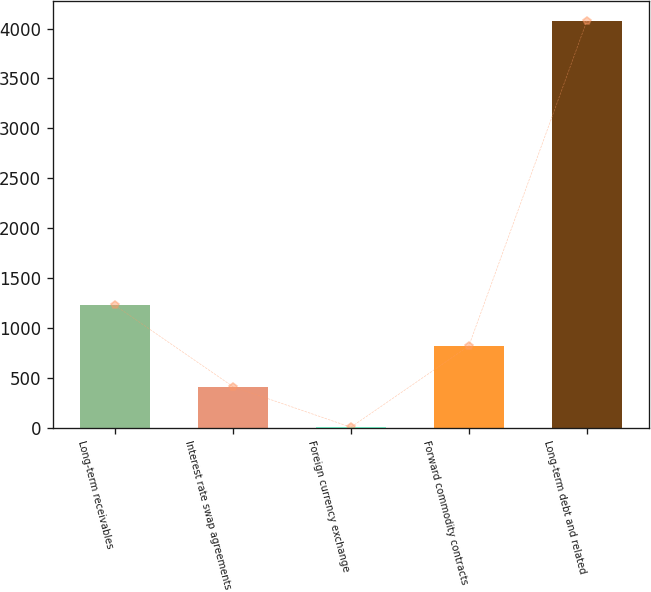Convert chart to OTSL. <chart><loc_0><loc_0><loc_500><loc_500><bar_chart><fcel>Long-term receivables<fcel>Interest rate swap agreements<fcel>Foreign currency exchange<fcel>Forward commodity contracts<fcel>Long-term debt and related<nl><fcel>1225.2<fcel>410.4<fcel>3<fcel>817.8<fcel>4077<nl></chart> 